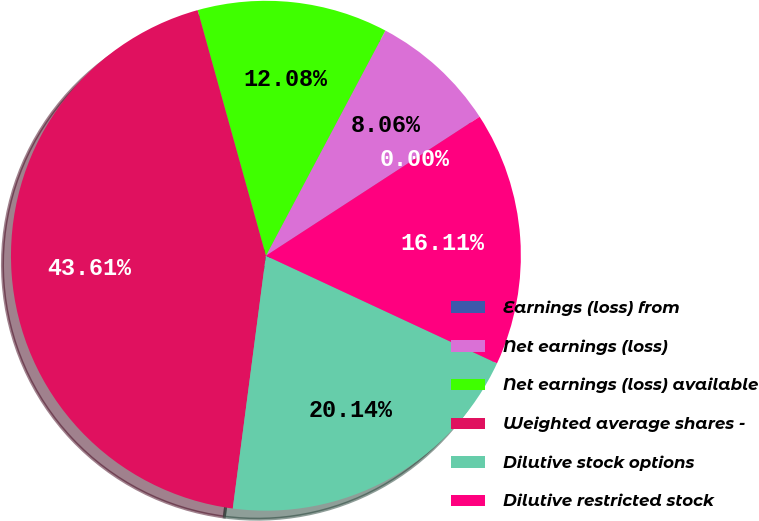Convert chart. <chart><loc_0><loc_0><loc_500><loc_500><pie_chart><fcel>Earnings (loss) from<fcel>Net earnings (loss)<fcel>Net earnings (loss) available<fcel>Weighted average shares -<fcel>Dilutive stock options<fcel>Dilutive restricted stock<nl><fcel>0.0%<fcel>8.06%<fcel>12.08%<fcel>43.61%<fcel>20.14%<fcel>16.11%<nl></chart> 